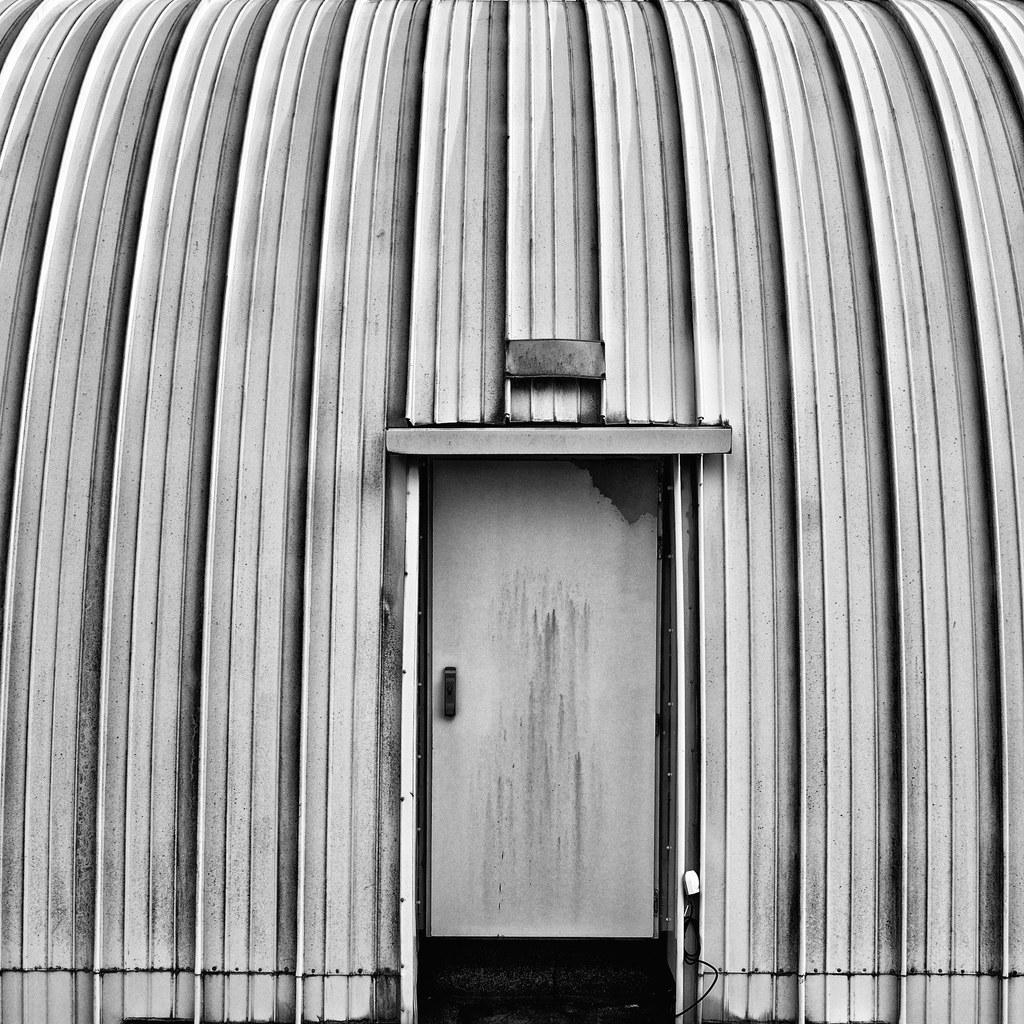What part of a house can be seen in the image? There is a part of a house wall in the image. What feature is present on the wall? The wall has a door. What can be used to open the door? The door has a handle. What additional detail can be observed on the wall? There are lines visible on the wall. What type of vessel is being carried by the truck in the image? There is no truck or vessel present in the image; it only features a part of a house wall with a door and lines. 